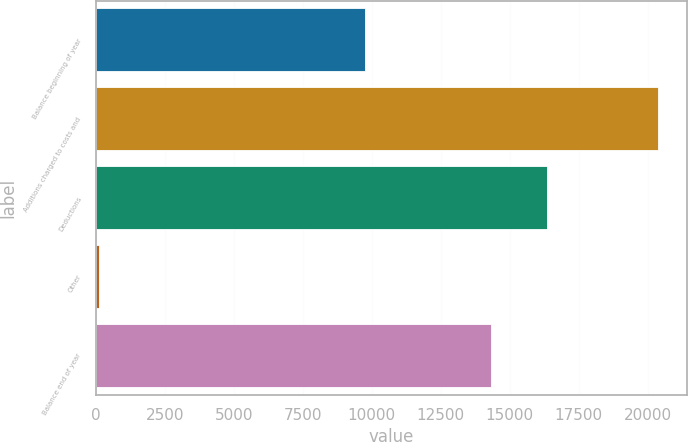Convert chart. <chart><loc_0><loc_0><loc_500><loc_500><bar_chart><fcel>Balance beginning of year<fcel>Additions charged to costs and<fcel>Deductions<fcel>Other<fcel>Balance end of year<nl><fcel>9755<fcel>20387<fcel>16363.8<fcel>109<fcel>14336<nl></chart> 